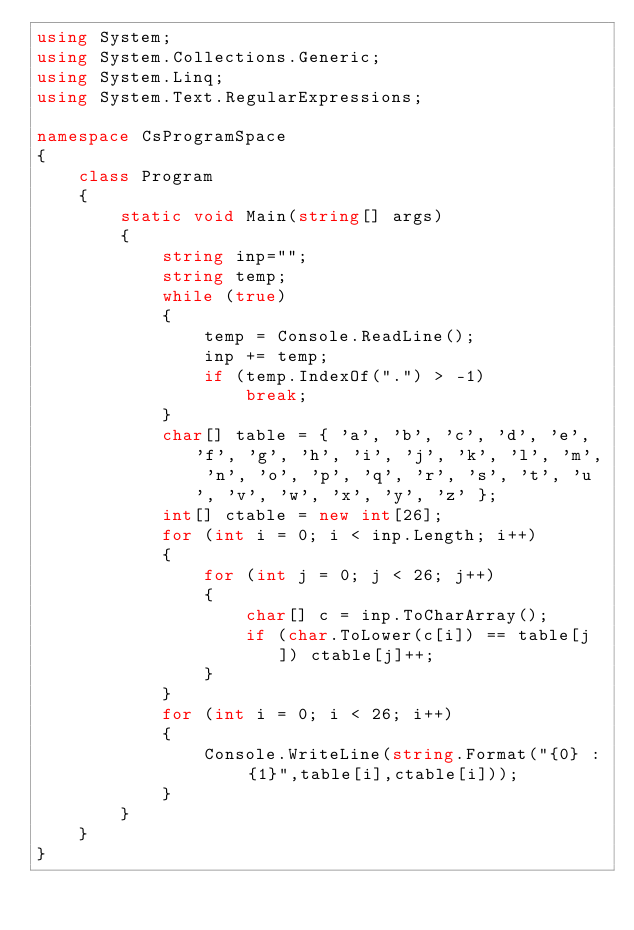<code> <loc_0><loc_0><loc_500><loc_500><_C#_>using System;
using System.Collections.Generic;
using System.Linq;
using System.Text.RegularExpressions;

namespace CsProgramSpace
{
    class Program
    {
        static void Main(string[] args)
        {
            string inp="";
            string temp;
            while (true)
            {
                temp = Console.ReadLine();
                inp += temp;
                if (temp.IndexOf(".") > -1)
                    break;
            }
            char[] table = { 'a', 'b', 'c', 'd', 'e', 'f', 'g', 'h', 'i', 'j', 'k', 'l', 'm', 'n', 'o', 'p', 'q', 'r', 's', 't', 'u', 'v', 'w', 'x', 'y', 'z' };
            int[] ctable = new int[26];
            for (int i = 0; i < inp.Length; i++)
            {
                for (int j = 0; j < 26; j++)
                {
                    char[] c = inp.ToCharArray();
                    if (char.ToLower(c[i]) == table[j]) ctable[j]++;
                }
            }
            for (int i = 0; i < 26; i++)
            {
                Console.WriteLine(string.Format("{0} : {1}",table[i],ctable[i]));
            }
        }
    }
}
</code> 